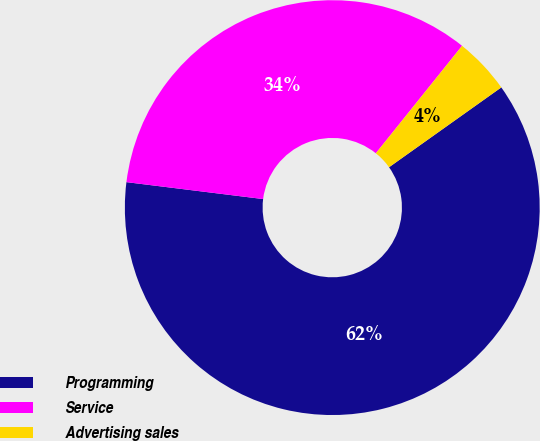Convert chart. <chart><loc_0><loc_0><loc_500><loc_500><pie_chart><fcel>Programming<fcel>Service<fcel>Advertising sales<nl><fcel>61.8%<fcel>33.8%<fcel>4.4%<nl></chart> 